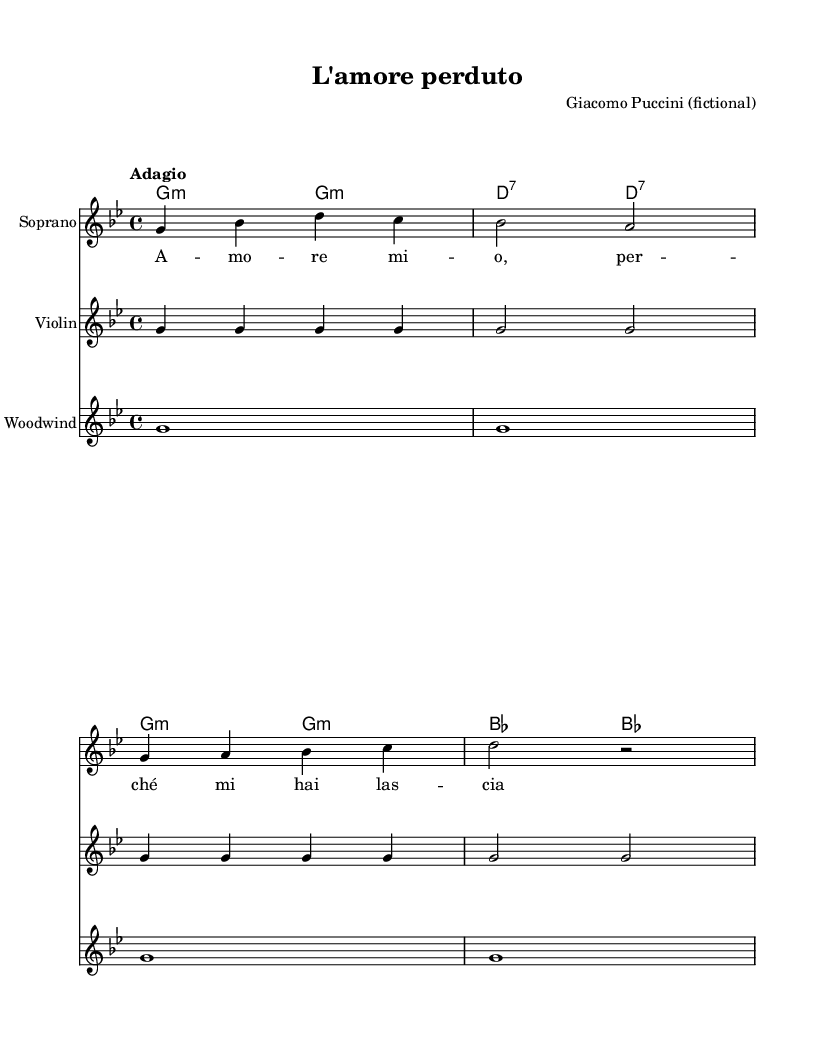What is the key signature of this music? The key signature is indicated by the number of sharps or flats at the beginning of the staff. In this case, the music is set in G minor, which has two flats (B flat and E flat).
Answer: G minor What is the time signature of the music? The time signature is noted at the beginning of the staff, typically shown as a fraction. Here, it is 4/4, indicating four beats per measure with a quarter note receiving one beat.
Answer: 4/4 What is the tempo marking for this piece? The tempo is indicated at the beginning of the score, usually written above the staff in text. This piece is marked “Adagio,” which typically means to play slowly.
Answer: Adagio How many measures are there in the soprano part? To determine the number of measures, count the number of vertical lines that separate the music into sections, which represent measures. There are four measures in the soprano part.
Answer: 4 What is the name of the fictional composer of this operatic piece? The composer is specified in the header section of the sheet music. It states that the piece is by Giacomo Puccini, though noted as fictional.
Answer: Giacomo Puccini What is the primary theme expressed in the lyrics? The lyrics, “Amo re mio, perché mi hai lasciato?” translate to “My love, why have you left me?” This indicates a theme of tragic love and longing, typical for Romantic era operas.
Answer: Tragic love What instruments are featured in this score? The instruments included in the score are listed under each staff. The piece features Soprano, Violin, and Woodwind instruments.
Answer: Soprano, Violin, Woodwind 